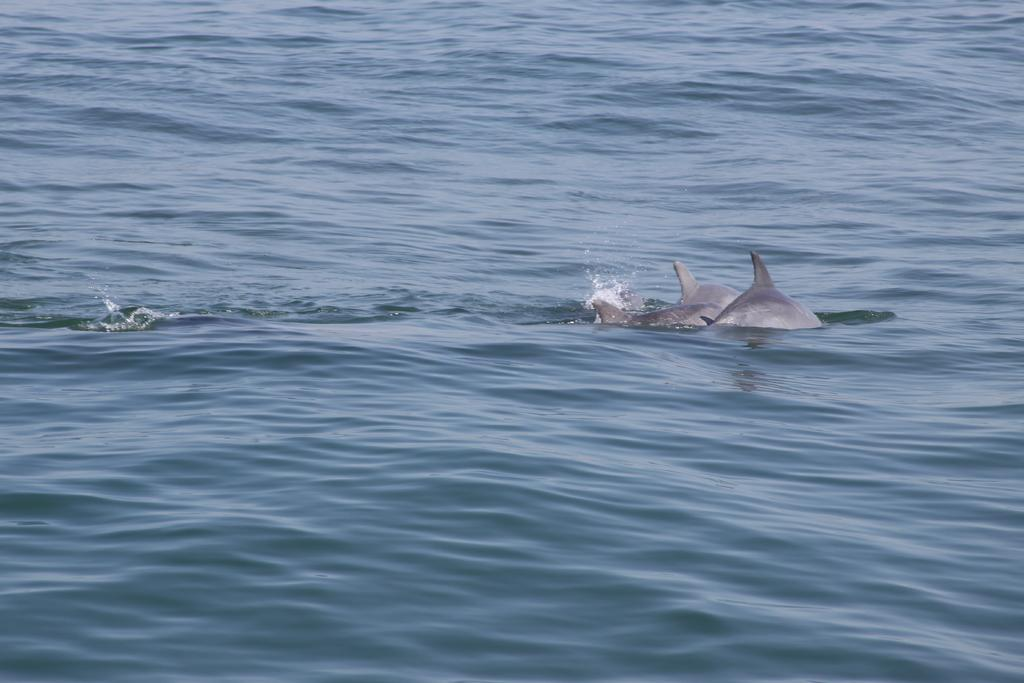What is visible in the image? There is water visible in the image. What can be found in the water? There are two sharks in the water. What type of pickle is being sold at the market in the image? There is no market or pickle present in the image; it features water with two sharks. What type of farm animals can be seen grazing in the image? There are no farm animals present in the image; it features water with two sharks. 